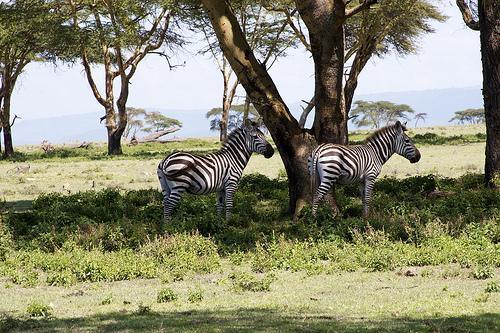How many zebras are there?
Give a very brief answer. 2. 